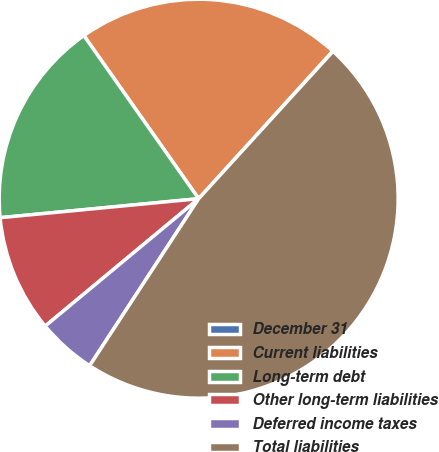Convert chart. <chart><loc_0><loc_0><loc_500><loc_500><pie_chart><fcel>December 31<fcel>Current liabilities<fcel>Long-term debt<fcel>Other long-term liabilities<fcel>Deferred income taxes<fcel>Total liabilities<nl><fcel>0.03%<fcel>21.5%<fcel>16.76%<fcel>9.51%<fcel>4.77%<fcel>47.44%<nl></chart> 